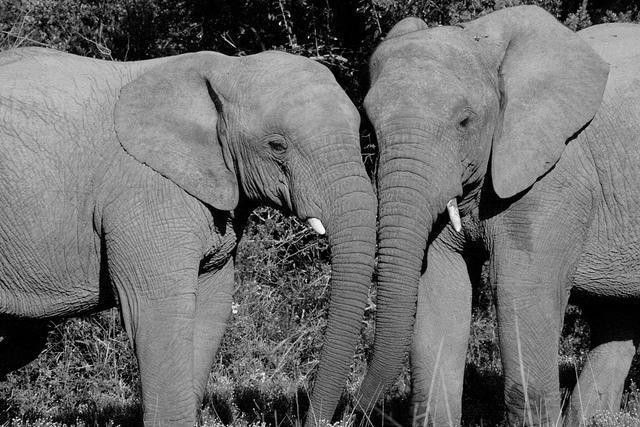How many elephants are there?
Give a very brief answer. 2. How many elephants can you see?
Give a very brief answer. 2. How many people are wearing glasses?
Give a very brief answer. 0. 